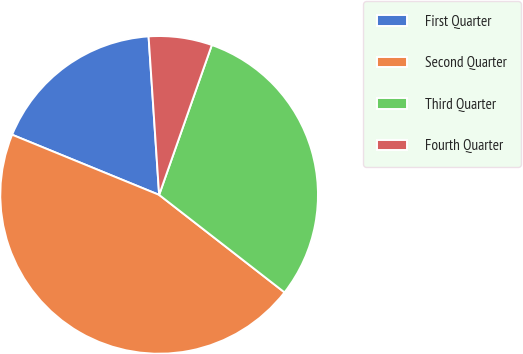Convert chart to OTSL. <chart><loc_0><loc_0><loc_500><loc_500><pie_chart><fcel>First Quarter<fcel>Second Quarter<fcel>Third Quarter<fcel>Fourth Quarter<nl><fcel>17.76%<fcel>45.66%<fcel>30.14%<fcel>6.44%<nl></chart> 